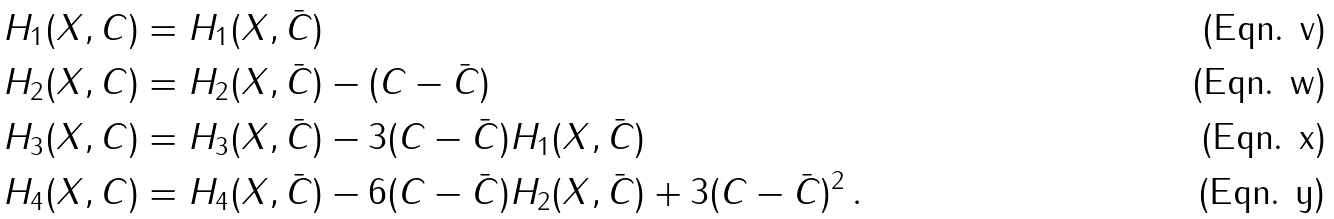<formula> <loc_0><loc_0><loc_500><loc_500>H _ { 1 } ( X , C ) & = H _ { 1 } ( X , \bar { C } ) \\ H _ { 2 } ( X , C ) & = H _ { 2 } ( X , \bar { C } ) - ( C - \bar { C } ) \\ H _ { 3 } ( X , C ) & = H _ { 3 } ( X , \bar { C } ) - 3 ( C - \bar { C } ) H _ { 1 } ( X , \bar { C } ) \\ H _ { 4 } ( X , C ) & = H _ { 4 } ( X , \bar { C } ) - 6 ( C - \bar { C } ) H _ { 2 } ( X , \bar { C } ) + 3 ( C - \bar { C } ) ^ { 2 } \, .</formula> 